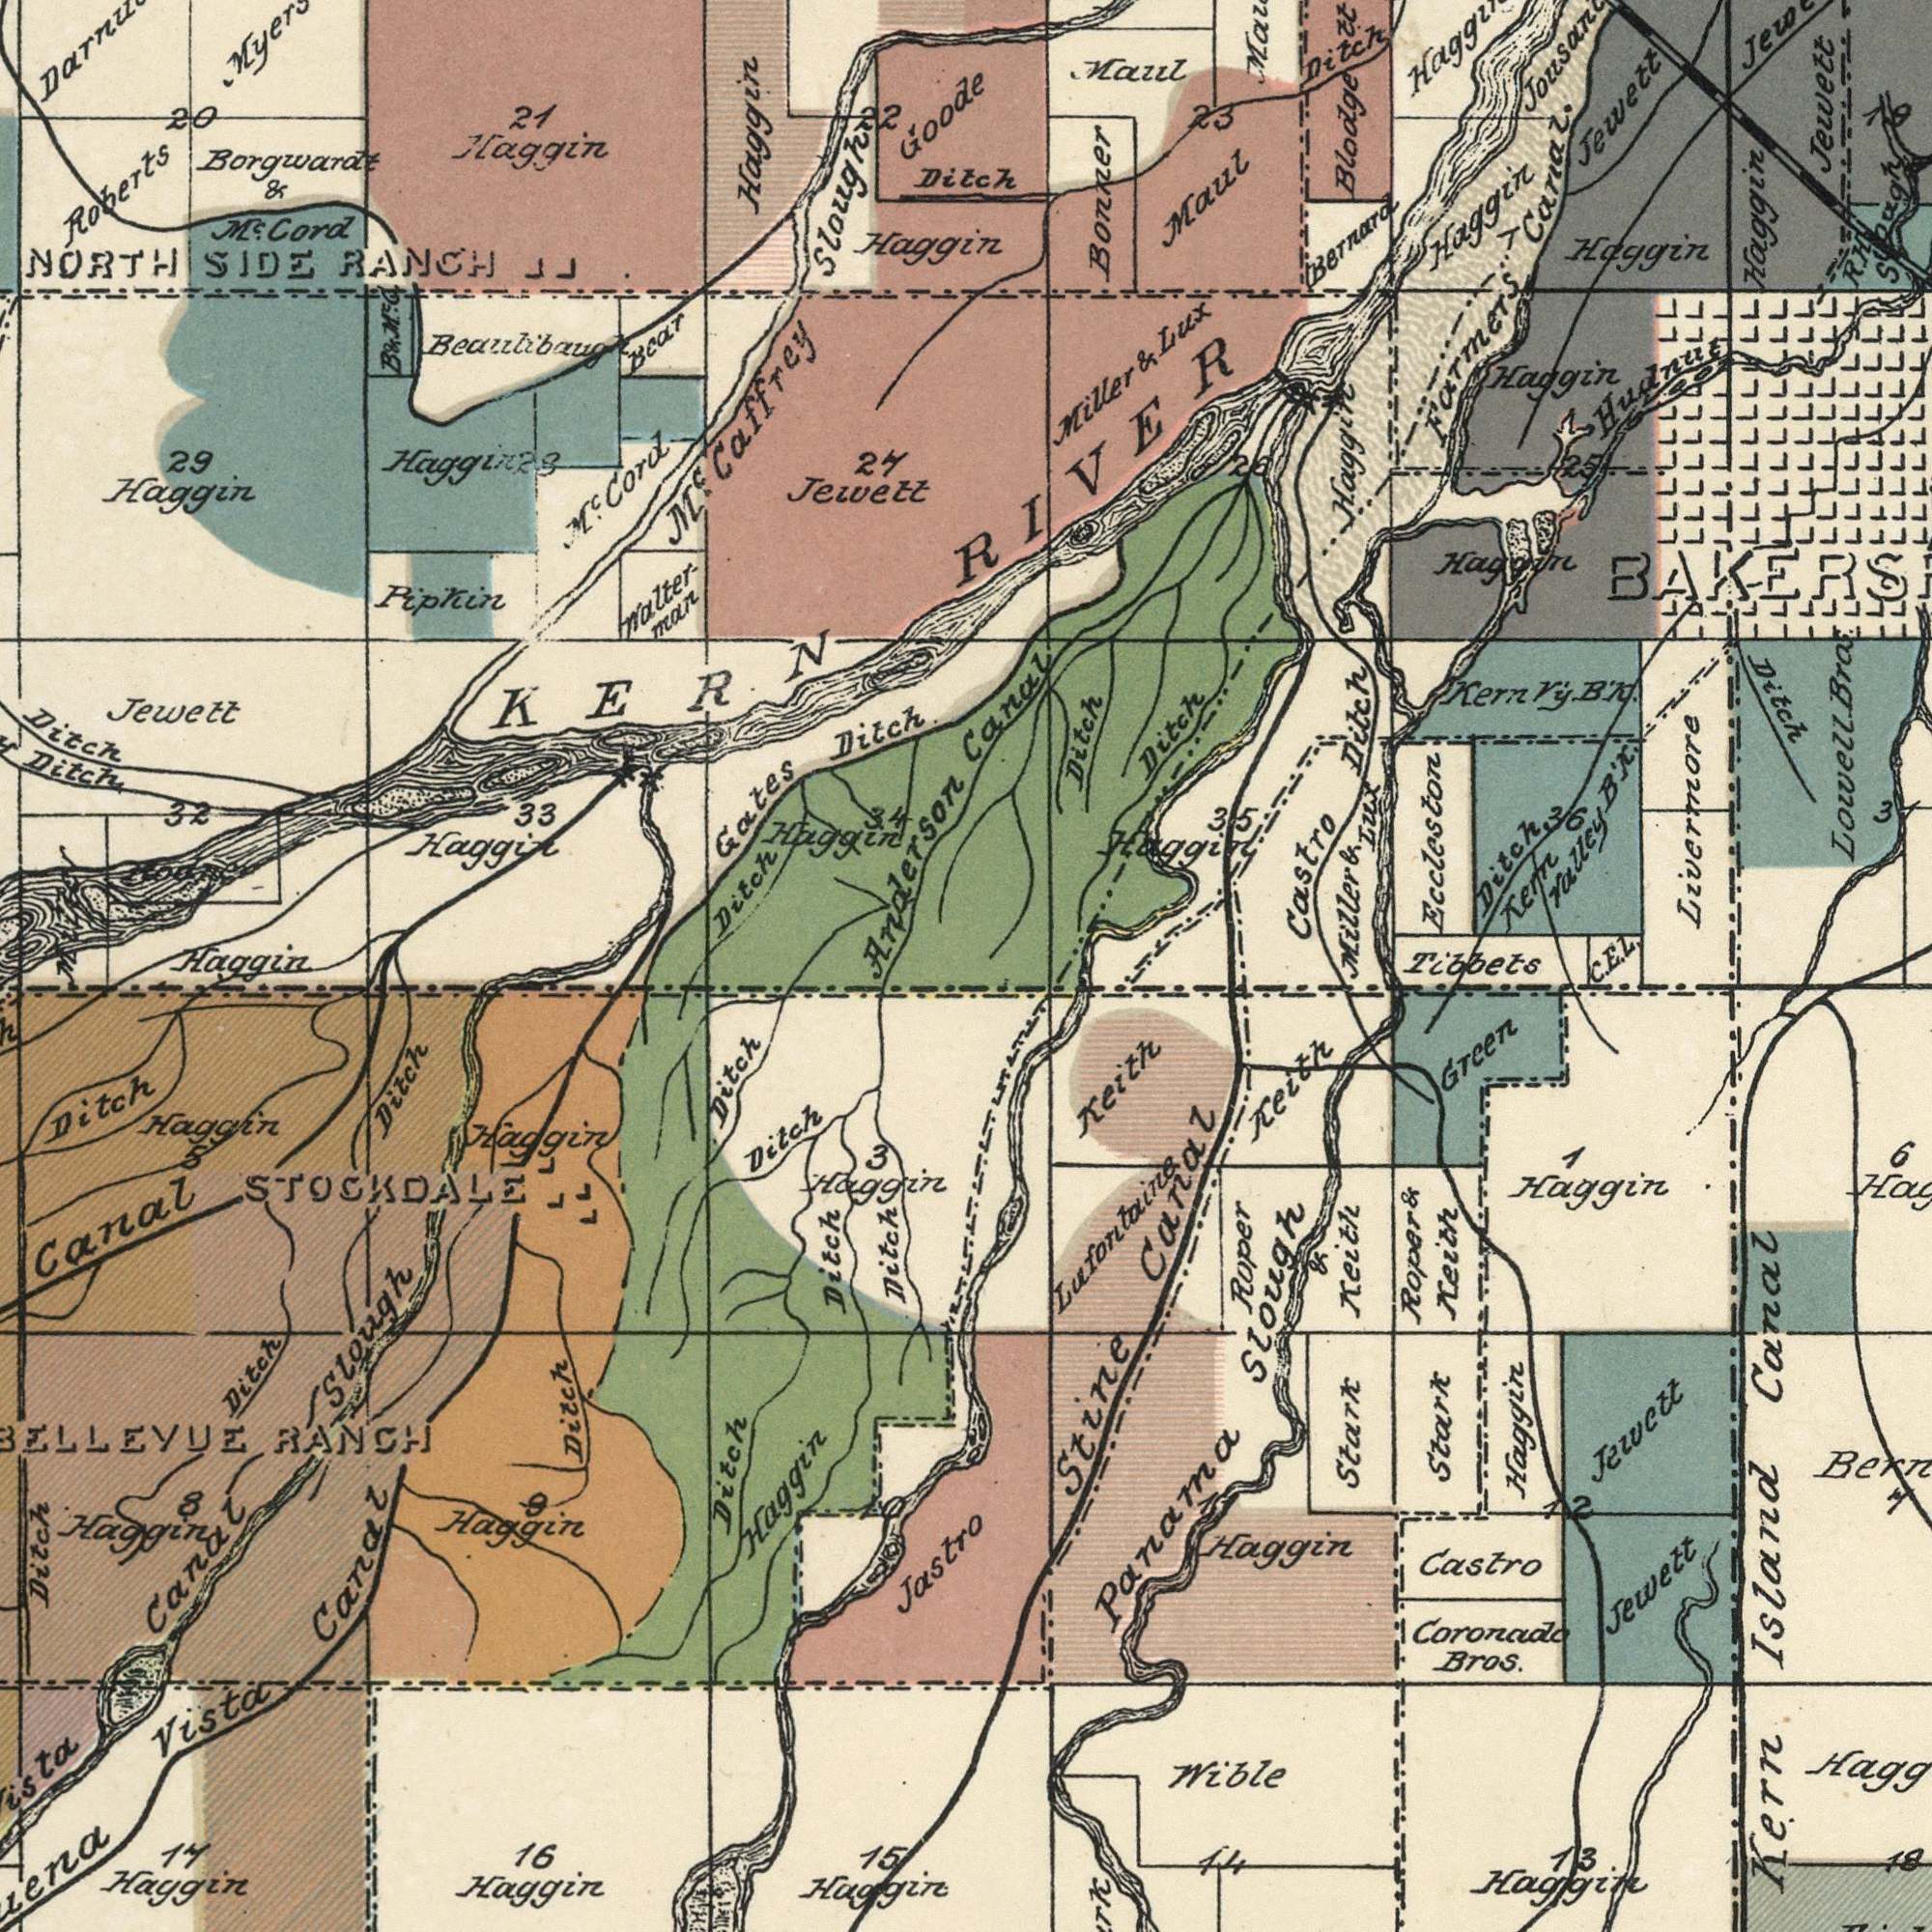What text appears in the bottom-right area of the image? Kern Island Canal Stark Wible Haggin Haggiin Coronade Bros. Castro Roper & Keith Stine Canal Roper & Keith Keith Bern Jewett Panama Slough Green Stark 14 Haggin Lufontaine Jewett Keith 6 13 18 7 Haggin 7 C. E. Tibbets 12 What text is visible in the upper-right corner? Ditch Canal Maul Bonner Haggin Blodge tt. Castro Ditch Haggin Formers Canal Z. Jewett Haggin Berrard Miller & Lux Ditch Ditch Haggin Ditch Kern Valley B'k. Ditch Maul Jewett Livermzore RIVER Lowell Bra Haggin Kern V'y. B'k. Haggin Haggin Eccleston 23 3 Miller & Lux 35 Haggin Maul Hudnut R. H Sough Ditch 36 26 25 Z. 19 What text is visible in the upper-left corner? NORTH SIDE RANCH Jewett Gates Ditch Ditch 33 Jewett Haggin Roberts M<sup>c</sup>. Caffrey Slough Haggin 27 Haggin 29 Haggin Bear Walter- mar Ditch Pipkin Haggin 21 Ditch M<sup>c</sup>. Cord Borgwarat & M<sup>c</sup> Cord Haggerz Goode 32 20 Anderson Beaulibaug KERN B & M<sup>c</sup>.G. Haggir 28 34 22 Mizen What text is visible in the lower-left corner? Vista Canal Haggin Haggin Haggin Haggin Ditch 15 Canal Slough Dilch Ditch 17 Ditch Canal BELLEUE RANCH Ditch Ditch Haggin Ditch 16 Ditch Jastro Ditch Ditck Haggin 8 Huggin Haggin STOCKDALE 9 5 Laggin Haggin 10 3 